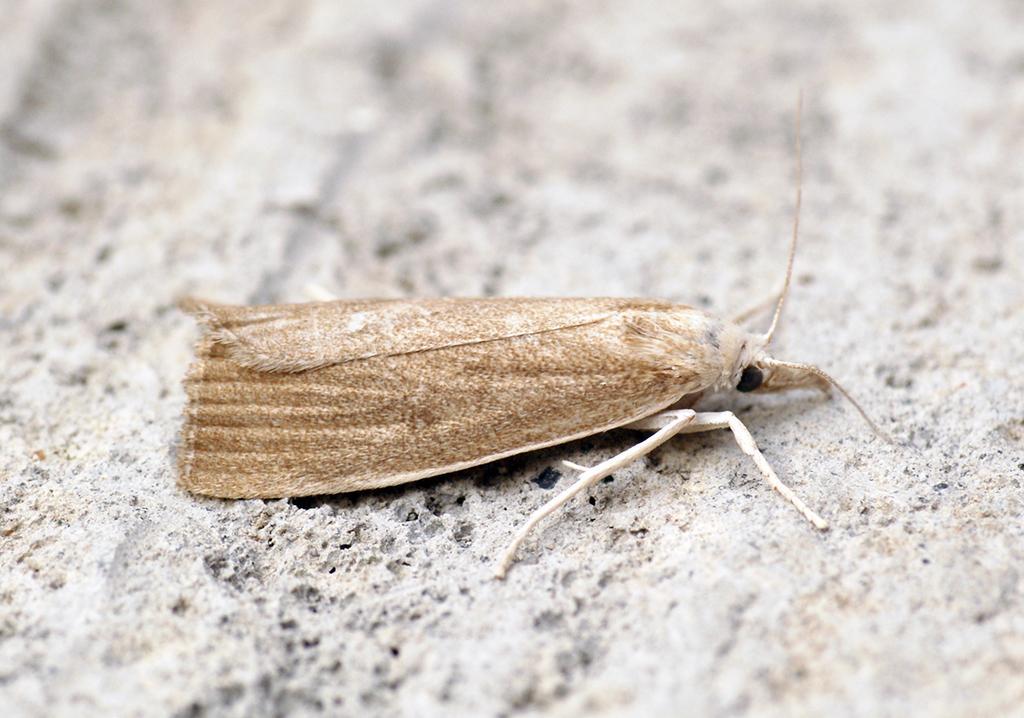Can you describe this image briefly? This image consists of an insect. At the bottom, there is a floor. The insect is in brown color. 